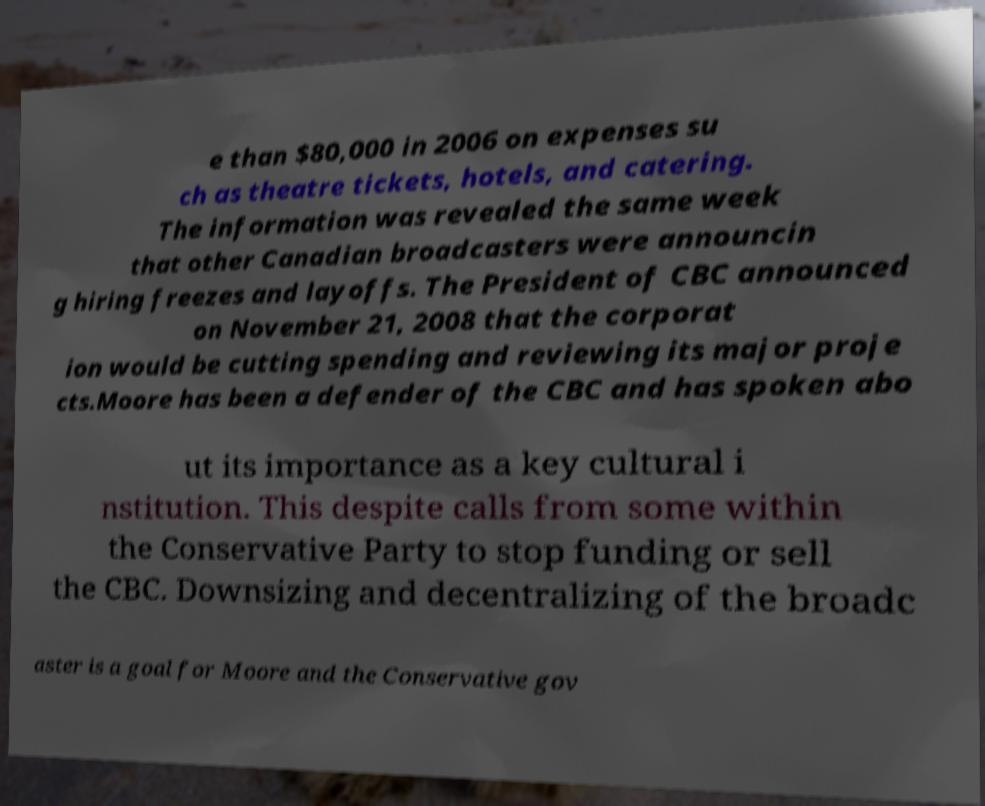Please identify and transcribe the text found in this image. e than $80,000 in 2006 on expenses su ch as theatre tickets, hotels, and catering. The information was revealed the same week that other Canadian broadcasters were announcin g hiring freezes and layoffs. The President of CBC announced on November 21, 2008 that the corporat ion would be cutting spending and reviewing its major proje cts.Moore has been a defender of the CBC and has spoken abo ut its importance as a key cultural i nstitution. This despite calls from some within the Conservative Party to stop funding or sell the CBC. Downsizing and decentralizing of the broadc aster is a goal for Moore and the Conservative gov 